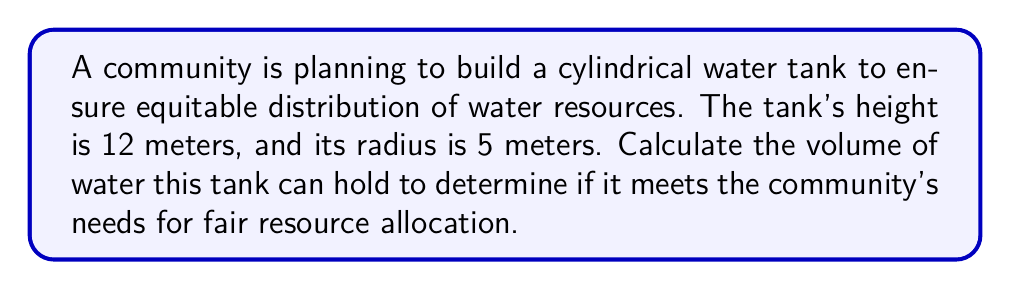Show me your answer to this math problem. To calculate the volume of a cylindrical tank, we use the formula:

$$V = \pi r^2 h$$

Where:
$V$ = volume
$\pi$ = pi (approximately 3.14159)
$r$ = radius of the base
$h$ = height of the cylinder

Given:
- Radius ($r$) = 5 meters
- Height ($h$) = 12 meters

Step 1: Substitute the values into the formula
$$V = \pi (5\text{ m})^2 (12\text{ m})$$

Step 2: Calculate the square of the radius
$$V = \pi (25\text{ m}^2) (12\text{ m})$$

Step 3: Multiply all the terms
$$V = 300\pi\text{ m}^3$$

Step 4: Calculate the final value (use 3.14159 for $\pi$)
$$V = 300 \times 3.14159\text{ m}^3 = 942.477\text{ m}^3$$

Therefore, the volume of the cylindrical water tank is approximately 942.477 cubic meters.
Answer: 942.477 m³ 